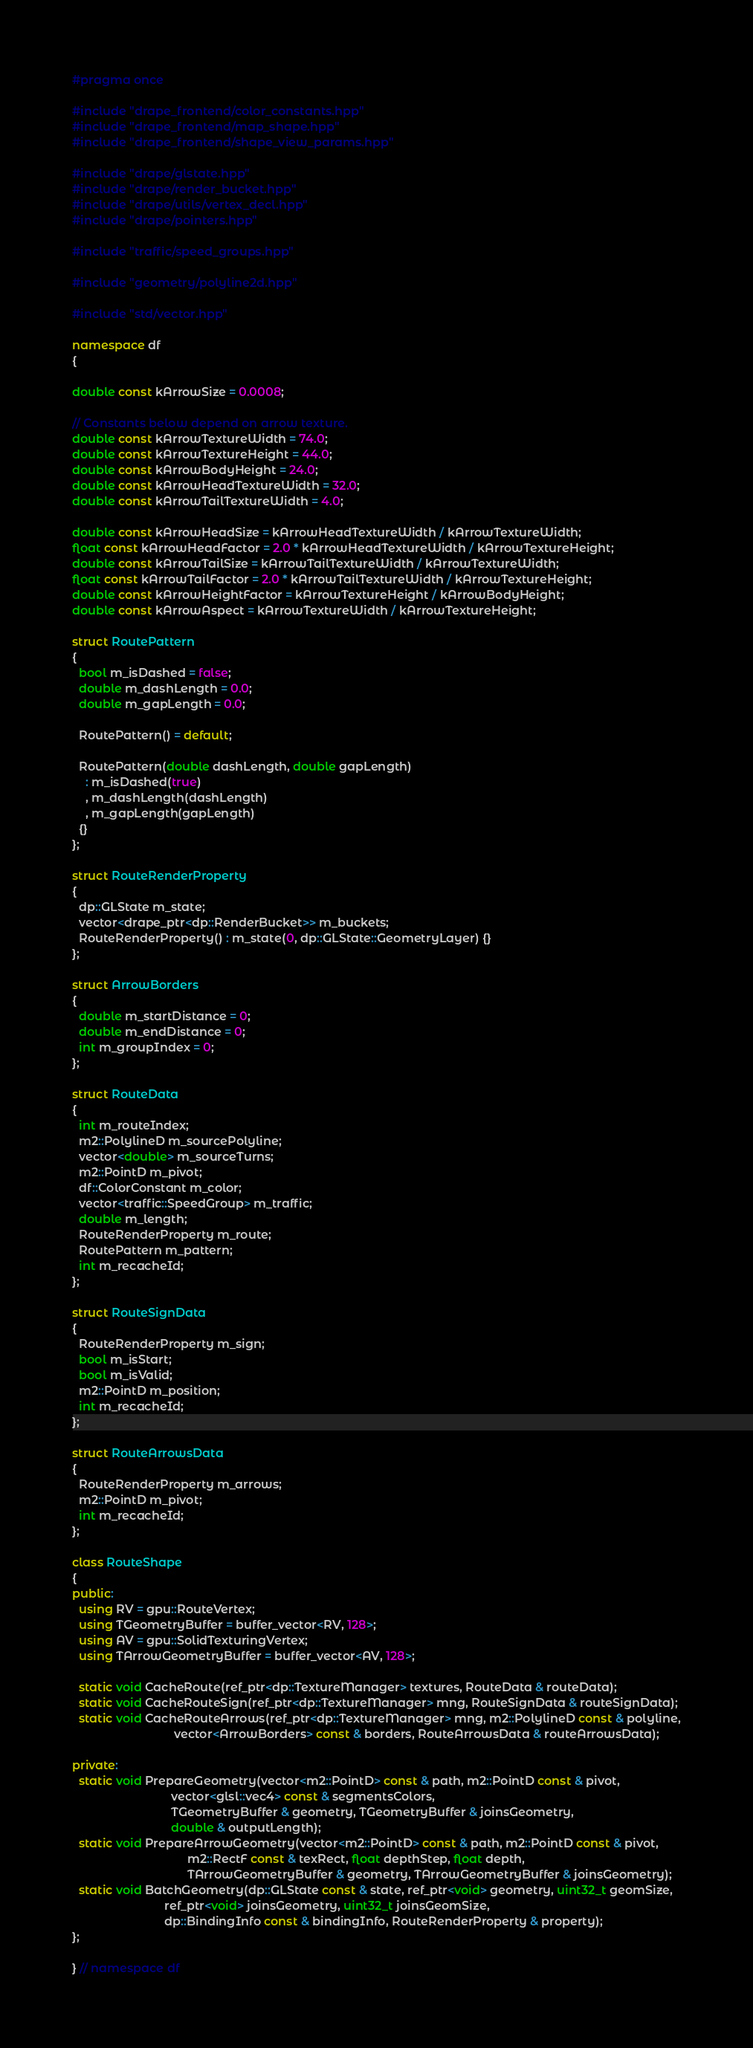<code> <loc_0><loc_0><loc_500><loc_500><_C++_>#pragma once

#include "drape_frontend/color_constants.hpp"
#include "drape_frontend/map_shape.hpp"
#include "drape_frontend/shape_view_params.hpp"

#include "drape/glstate.hpp"
#include "drape/render_bucket.hpp"
#include "drape/utils/vertex_decl.hpp"
#include "drape/pointers.hpp"

#include "traffic/speed_groups.hpp"

#include "geometry/polyline2d.hpp"

#include "std/vector.hpp"

namespace df
{

double const kArrowSize = 0.0008;

// Constants below depend on arrow texture.
double const kArrowTextureWidth = 74.0;
double const kArrowTextureHeight = 44.0;
double const kArrowBodyHeight = 24.0;
double const kArrowHeadTextureWidth = 32.0;
double const kArrowTailTextureWidth = 4.0;

double const kArrowHeadSize = kArrowHeadTextureWidth / kArrowTextureWidth;
float const kArrowHeadFactor = 2.0 * kArrowHeadTextureWidth / kArrowTextureHeight;
double const kArrowTailSize = kArrowTailTextureWidth / kArrowTextureWidth;
float const kArrowTailFactor = 2.0 * kArrowTailTextureWidth / kArrowTextureHeight;
double const kArrowHeightFactor = kArrowTextureHeight / kArrowBodyHeight;
double const kArrowAspect = kArrowTextureWidth / kArrowTextureHeight;

struct RoutePattern
{
  bool m_isDashed = false;
  double m_dashLength = 0.0;
  double m_gapLength = 0.0;

  RoutePattern() = default;

  RoutePattern(double dashLength, double gapLength)
    : m_isDashed(true)
    , m_dashLength(dashLength)
    , m_gapLength(gapLength)
  {}
};

struct RouteRenderProperty
{
  dp::GLState m_state;
  vector<drape_ptr<dp::RenderBucket>> m_buckets;
  RouteRenderProperty() : m_state(0, dp::GLState::GeometryLayer) {}
};

struct ArrowBorders
{
  double m_startDistance = 0;
  double m_endDistance = 0;
  int m_groupIndex = 0;
};

struct RouteData
{
  int m_routeIndex;
  m2::PolylineD m_sourcePolyline;
  vector<double> m_sourceTurns;
  m2::PointD m_pivot;
  df::ColorConstant m_color;
  vector<traffic::SpeedGroup> m_traffic;
  double m_length;
  RouteRenderProperty m_route;
  RoutePattern m_pattern;
  int m_recacheId;
};

struct RouteSignData
{
  RouteRenderProperty m_sign;
  bool m_isStart;
  bool m_isValid;
  m2::PointD m_position;
  int m_recacheId;
};

struct RouteArrowsData
{
  RouteRenderProperty m_arrows;
  m2::PointD m_pivot;
  int m_recacheId;
};

class RouteShape
{
public:
  using RV = gpu::RouteVertex;
  using TGeometryBuffer = buffer_vector<RV, 128>;
  using AV = gpu::SolidTexturingVertex;
  using TArrowGeometryBuffer = buffer_vector<AV, 128>;

  static void CacheRoute(ref_ptr<dp::TextureManager> textures, RouteData & routeData);
  static void CacheRouteSign(ref_ptr<dp::TextureManager> mng, RouteSignData & routeSignData);
  static void CacheRouteArrows(ref_ptr<dp::TextureManager> mng, m2::PolylineD const & polyline,
                               vector<ArrowBorders> const & borders, RouteArrowsData & routeArrowsData);

private:
  static void PrepareGeometry(vector<m2::PointD> const & path, m2::PointD const & pivot,
                              vector<glsl::vec4> const & segmentsColors,
                              TGeometryBuffer & geometry, TGeometryBuffer & joinsGeometry,
                              double & outputLength);
  static void PrepareArrowGeometry(vector<m2::PointD> const & path, m2::PointD const & pivot,
                                   m2::RectF const & texRect, float depthStep, float depth,
                                   TArrowGeometryBuffer & geometry, TArrowGeometryBuffer & joinsGeometry);
  static void BatchGeometry(dp::GLState const & state, ref_ptr<void> geometry, uint32_t geomSize,
                            ref_ptr<void> joinsGeometry, uint32_t joinsGeomSize,
                            dp::BindingInfo const & bindingInfo, RouteRenderProperty & property);
};

} // namespace df
</code> 